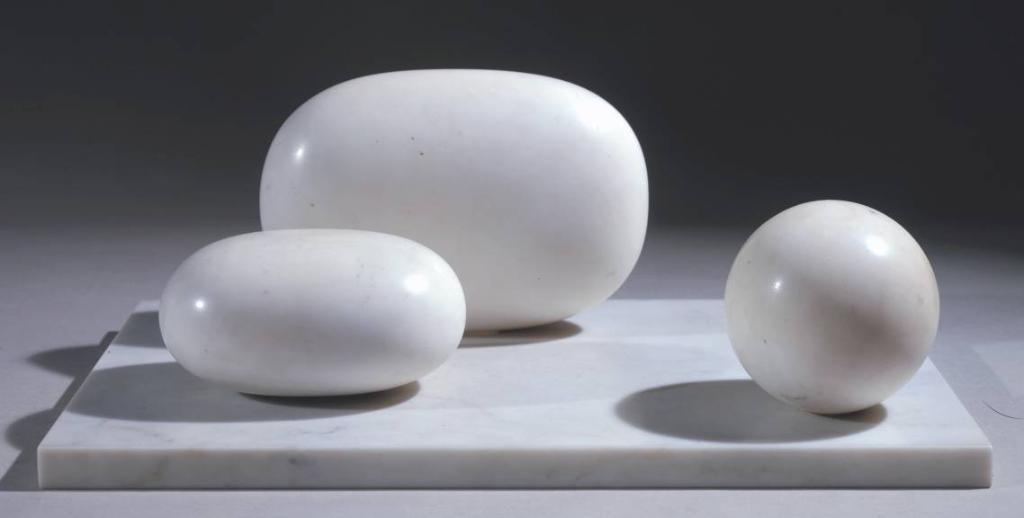What type of objects can be seen in the image? There are stones in the image. Can you describe the stones in the image? The stones have different shapes. What type of government is depicted in the image? There is no government depicted in the image; it features stones with different shapes. What unit of measurement is used to determine the size of the stones in the image? The provided facts do not mention any specific unit of measurement for the stones in the image. 